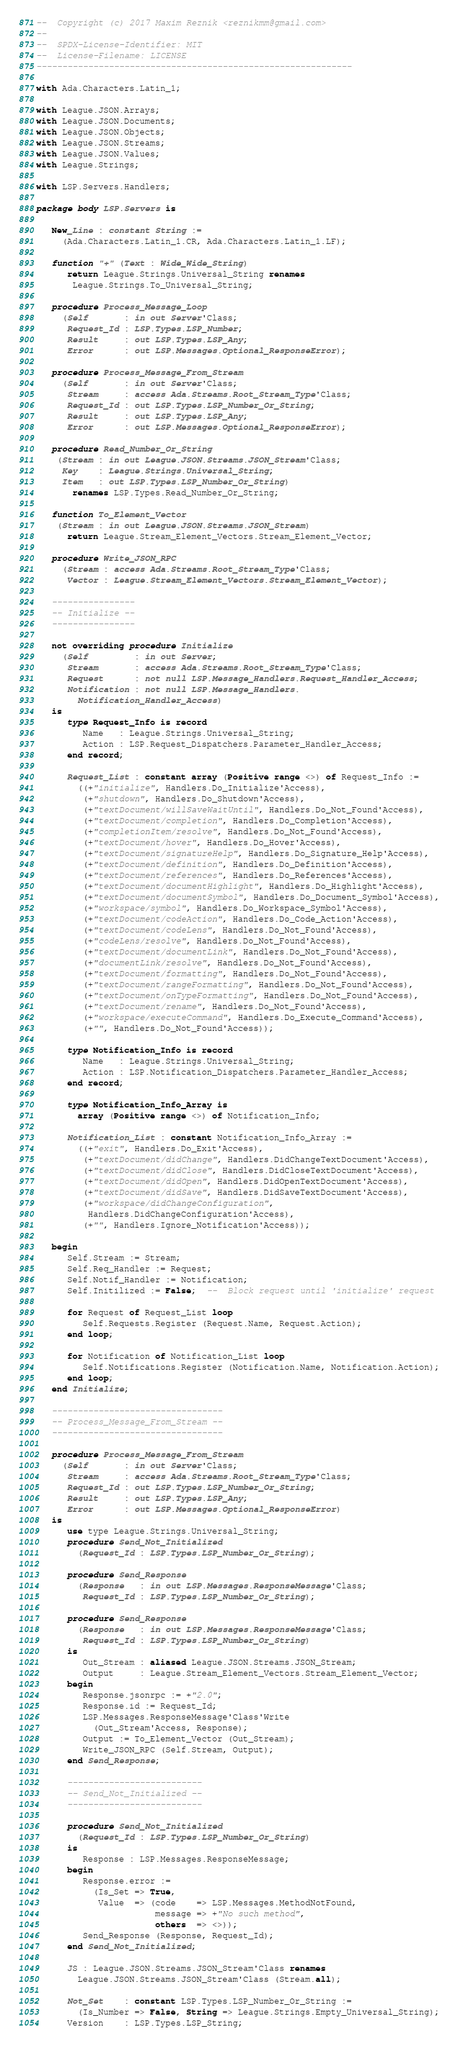<code> <loc_0><loc_0><loc_500><loc_500><_Ada_>--  Copyright (c) 2017 Maxim Reznik <reznikmm@gmail.com>
--
--  SPDX-License-Identifier: MIT
--  License-Filename: LICENSE
-------------------------------------------------------------

with Ada.Characters.Latin_1;

with League.JSON.Arrays;
with League.JSON.Documents;
with League.JSON.Objects;
with League.JSON.Streams;
with League.JSON.Values;
with League.Strings;

with LSP.Servers.Handlers;

package body LSP.Servers is

   New_Line : constant String :=
     (Ada.Characters.Latin_1.CR, Ada.Characters.Latin_1.LF);

   function "+" (Text : Wide_Wide_String)
      return League.Strings.Universal_String renames
       League.Strings.To_Universal_String;

   procedure Process_Message_Loop
     (Self       : in out Server'Class;
      Request_Id : LSP.Types.LSP_Number;
      Result     : out LSP.Types.LSP_Any;
      Error      : out LSP.Messages.Optional_ResponseError);

   procedure Process_Message_From_Stream
     (Self       : in out Server'Class;
      Stream     : access Ada.Streams.Root_Stream_Type'Class;
      Request_Id : out LSP.Types.LSP_Number_Or_String;
      Result     : out LSP.Types.LSP_Any;
      Error      : out LSP.Messages.Optional_ResponseError);

   procedure Read_Number_Or_String
    (Stream : in out League.JSON.Streams.JSON_Stream'Class;
     Key    : League.Strings.Universal_String;
     Item   : out LSP.Types.LSP_Number_Or_String)
       renames LSP.Types.Read_Number_Or_String;

   function To_Element_Vector
    (Stream : in out League.JSON.Streams.JSON_Stream)
      return League.Stream_Element_Vectors.Stream_Element_Vector;

   procedure Write_JSON_RPC
     (Stream : access Ada.Streams.Root_Stream_Type'Class;
      Vector : League.Stream_Element_Vectors.Stream_Element_Vector);

   ----------------
   -- Initialize --
   ----------------

   not overriding procedure Initialize
     (Self         : in out Server;
      Stream       : access Ada.Streams.Root_Stream_Type'Class;
      Request      : not null LSP.Message_Handlers.Request_Handler_Access;
      Notification : not null LSP.Message_Handlers.
        Notification_Handler_Access)
   is
      type Request_Info is record
         Name   : League.Strings.Universal_String;
         Action : LSP.Request_Dispatchers.Parameter_Handler_Access;
      end record;

      Request_List : constant array (Positive range <>) of Request_Info :=
        ((+"initialize", Handlers.Do_Initialize'Access),
         (+"shutdown", Handlers.Do_Shutdown'Access),
         (+"textDocument/willSaveWaitUntil", Handlers.Do_Not_Found'Access),
         (+"textDocument/completion", Handlers.Do_Completion'Access),
         (+"completionItem/resolve", Handlers.Do_Not_Found'Access),
         (+"textDocument/hover", Handlers.Do_Hover'Access),
         (+"textDocument/signatureHelp", Handlers.Do_Signature_Help'Access),
         (+"textDocument/definition", Handlers.Do_Definition'Access),
         (+"textDocument/references", Handlers.Do_References'Access),
         (+"textDocument/documentHighlight", Handlers.Do_Highlight'Access),
         (+"textDocument/documentSymbol", Handlers.Do_Document_Symbol'Access),
         (+"workspace/symbol", Handlers.Do_Workspace_Symbol'Access),
         (+"textDocument/codeAction", Handlers.Do_Code_Action'Access),
         (+"textDocument/codeLens", Handlers.Do_Not_Found'Access),
         (+"codeLens/resolve", Handlers.Do_Not_Found'Access),
         (+"textDocument/documentLink", Handlers.Do_Not_Found'Access),
         (+"documentLink/resolve", Handlers.Do_Not_Found'Access),
         (+"textDocument/formatting", Handlers.Do_Not_Found'Access),
         (+"textDocument/rangeFormatting", Handlers.Do_Not_Found'Access),
         (+"textDocument/onTypeFormatting", Handlers.Do_Not_Found'Access),
         (+"textDocument/rename", Handlers.Do_Not_Found'Access),
         (+"workspace/executeCommand", Handlers.Do_Execute_Command'Access),
         (+"", Handlers.Do_Not_Found'Access));

      type Notification_Info is record
         Name   : League.Strings.Universal_String;
         Action : LSP.Notification_Dispatchers.Parameter_Handler_Access;
      end record;

      type Notification_Info_Array is
        array (Positive range <>) of Notification_Info;

      Notification_List : constant Notification_Info_Array :=
        ((+"exit", Handlers.Do_Exit'Access),
         (+"textDocument/didChange", Handlers.DidChangeTextDocument'Access),
         (+"textDocument/didClose", Handlers.DidCloseTextDocument'Access),
         (+"textDocument/didOpen", Handlers.DidOpenTextDocument'Access),
         (+"textDocument/didSave", Handlers.DidSaveTextDocument'Access),
         (+"workspace/didChangeConfiguration",
          Handlers.DidChangeConfiguration'Access),
         (+"", Handlers.Ignore_Notification'Access));

   begin
      Self.Stream := Stream;
      Self.Req_Handler := Request;
      Self.Notif_Handler := Notification;
      Self.Initilized := False;  --  Block request until 'initialize' request

      for Request of Request_List loop
         Self.Requests.Register (Request.Name, Request.Action);
      end loop;

      for Notification of Notification_List loop
         Self.Notifications.Register (Notification.Name, Notification.Action);
      end loop;
   end Initialize;

   ---------------------------------
   -- Process_Message_From_Stream --
   ---------------------------------

   procedure Process_Message_From_Stream
     (Self       : in out Server'Class;
      Stream     : access Ada.Streams.Root_Stream_Type'Class;
      Request_Id : out LSP.Types.LSP_Number_Or_String;
      Result     : out LSP.Types.LSP_Any;
      Error      : out LSP.Messages.Optional_ResponseError)
   is
      use type League.Strings.Universal_String;
      procedure Send_Not_Initialized
        (Request_Id : LSP.Types.LSP_Number_Or_String);

      procedure Send_Response
        (Response   : in out LSP.Messages.ResponseMessage'Class;
         Request_Id : LSP.Types.LSP_Number_Or_String);

      procedure Send_Response
        (Response   : in out LSP.Messages.ResponseMessage'Class;
         Request_Id : LSP.Types.LSP_Number_Or_String)
      is
         Out_Stream : aliased League.JSON.Streams.JSON_Stream;
         Output     : League.Stream_Element_Vectors.Stream_Element_Vector;
      begin
         Response.jsonrpc := +"2.0";
         Response.id := Request_Id;
         LSP.Messages.ResponseMessage'Class'Write
           (Out_Stream'Access, Response);
         Output := To_Element_Vector (Out_Stream);
         Write_JSON_RPC (Self.Stream, Output);
      end Send_Response;

      --------------------------
      -- Send_Not_Initialized --
      --------------------------

      procedure Send_Not_Initialized
        (Request_Id : LSP.Types.LSP_Number_Or_String)
      is
         Response : LSP.Messages.ResponseMessage;
      begin
         Response.error :=
           (Is_Set => True,
            Value  => (code    => LSP.Messages.MethodNotFound,
                       message => +"No such method",
                       others  => <>));
         Send_Response (Response, Request_Id);
      end Send_Not_Initialized;

      JS : League.JSON.Streams.JSON_Stream'Class renames
        League.JSON.Streams.JSON_Stream'Class (Stream.all);

      Not_Set    : constant LSP.Types.LSP_Number_Or_String :=
        (Is_Number => False, String => League.Strings.Empty_Universal_String);
      Version    : LSP.Types.LSP_String;</code> 